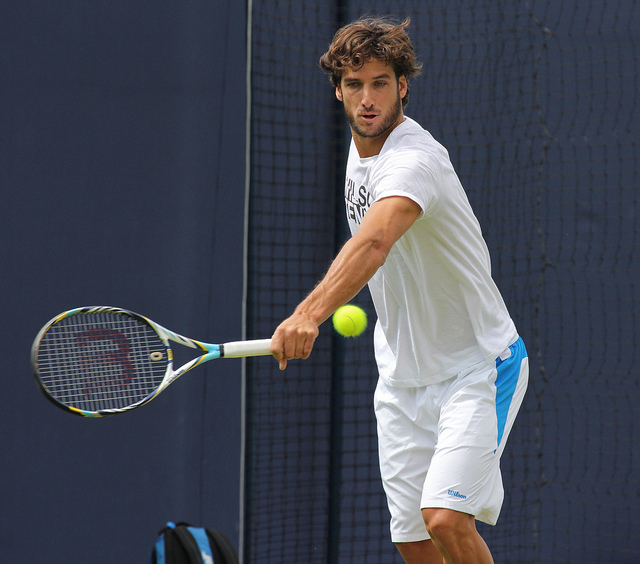How many backpacks are in the picture? There are no backpacks visible in the image. The focus is on a tennis player in mid-action as he is about to hit a tennis ball with his racket. 